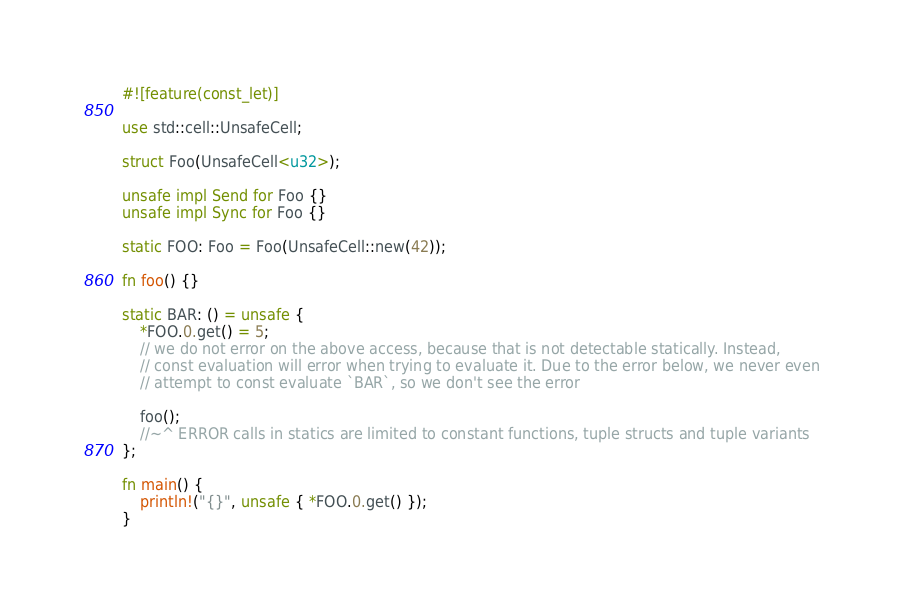Convert code to text. <code><loc_0><loc_0><loc_500><loc_500><_Rust_>#![feature(const_let)]

use std::cell::UnsafeCell;

struct Foo(UnsafeCell<u32>);

unsafe impl Send for Foo {}
unsafe impl Sync for Foo {}

static FOO: Foo = Foo(UnsafeCell::new(42));

fn foo() {}

static BAR: () = unsafe {
    *FOO.0.get() = 5;
    // we do not error on the above access, because that is not detectable statically. Instead,
    // const evaluation will error when trying to evaluate it. Due to the error below, we never even
    // attempt to const evaluate `BAR`, so we don't see the error

    foo();
    //~^ ERROR calls in statics are limited to constant functions, tuple structs and tuple variants
};

fn main() {
    println!("{}", unsafe { *FOO.0.get() });
}
</code> 